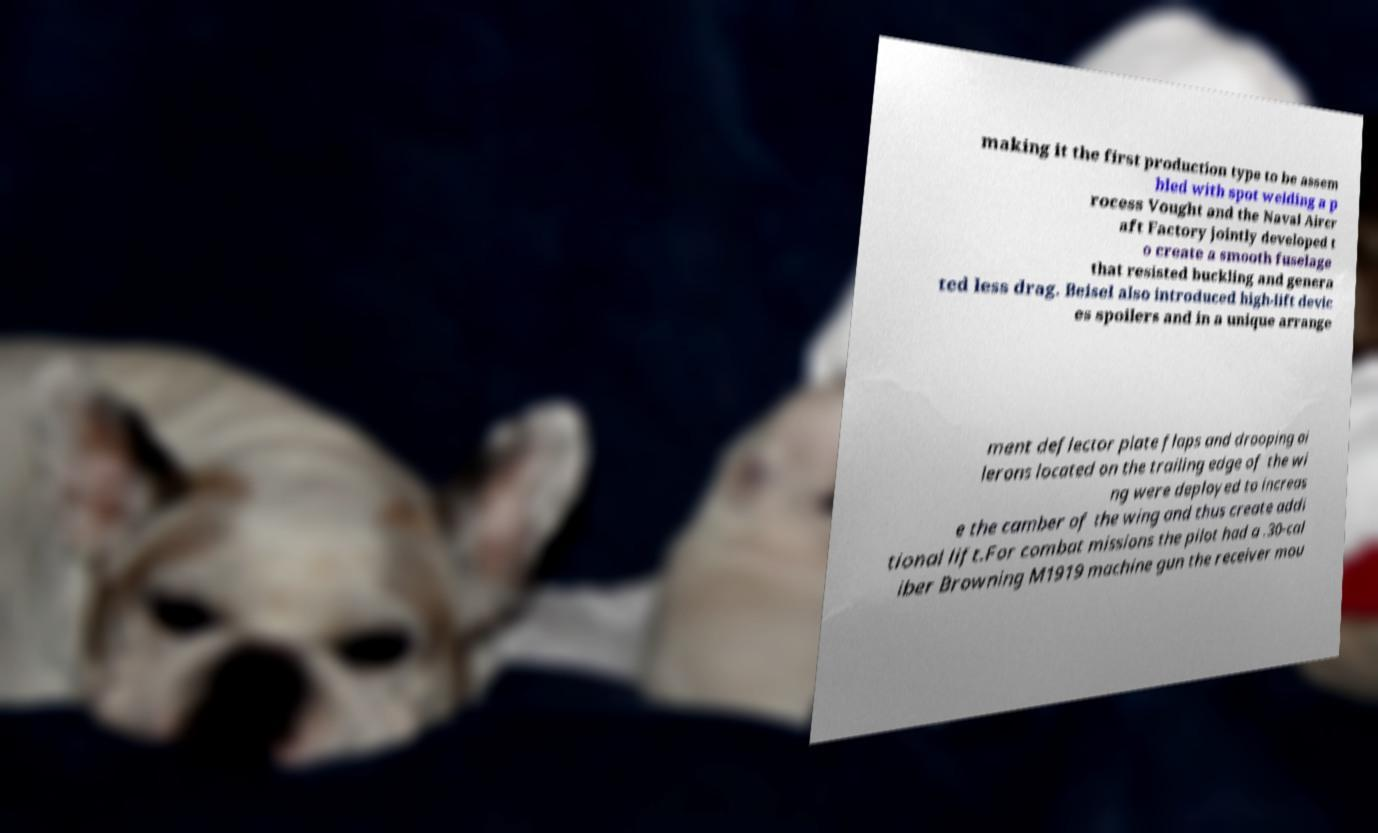There's text embedded in this image that I need extracted. Can you transcribe it verbatim? making it the first production type to be assem bled with spot welding a p rocess Vought and the Naval Aircr aft Factory jointly developed t o create a smooth fuselage that resisted buckling and genera ted less drag. Beisel also introduced high-lift devic es spoilers and in a unique arrange ment deflector plate flaps and drooping ai lerons located on the trailing edge of the wi ng were deployed to increas e the camber of the wing and thus create addi tional lift.For combat missions the pilot had a .30-cal iber Browning M1919 machine gun the receiver mou 